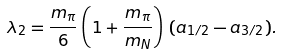Convert formula to latex. <formula><loc_0><loc_0><loc_500><loc_500>\lambda _ { 2 } = \frac { m _ { \pi } } { 6 } \left ( 1 + \frac { m _ { \pi } } { m _ { N } } \right ) \, ( a _ { 1 / 2 } - a _ { 3 / 2 } ) .</formula> 